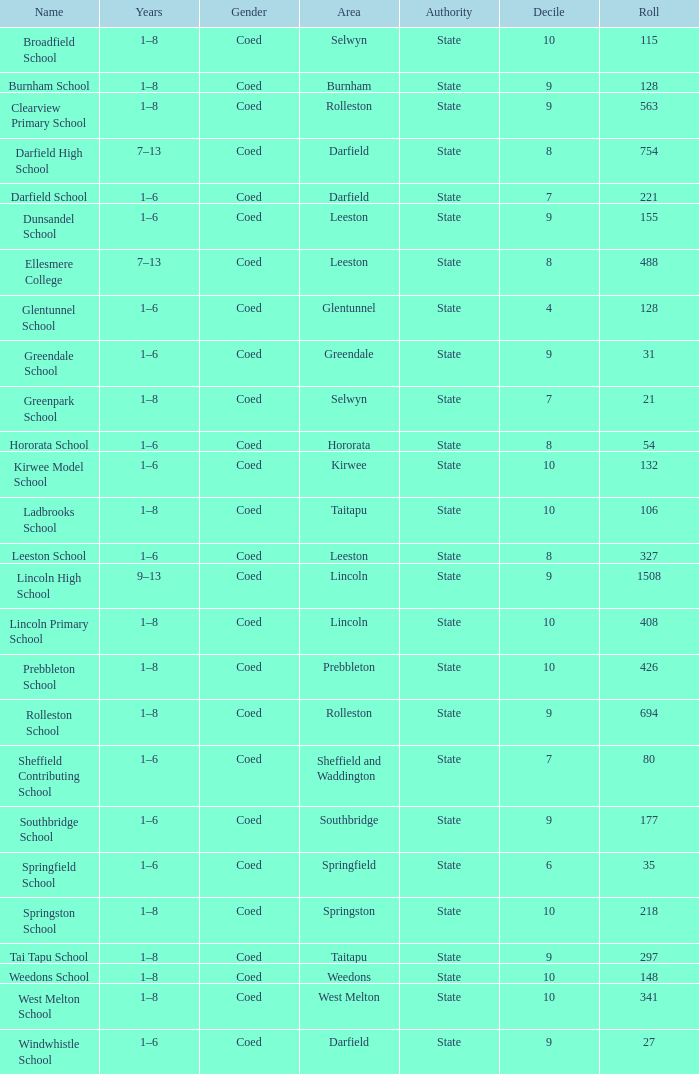Which name has a Roll larger than 297, and Years of 7–13? Darfield High School, Ellesmere College. 